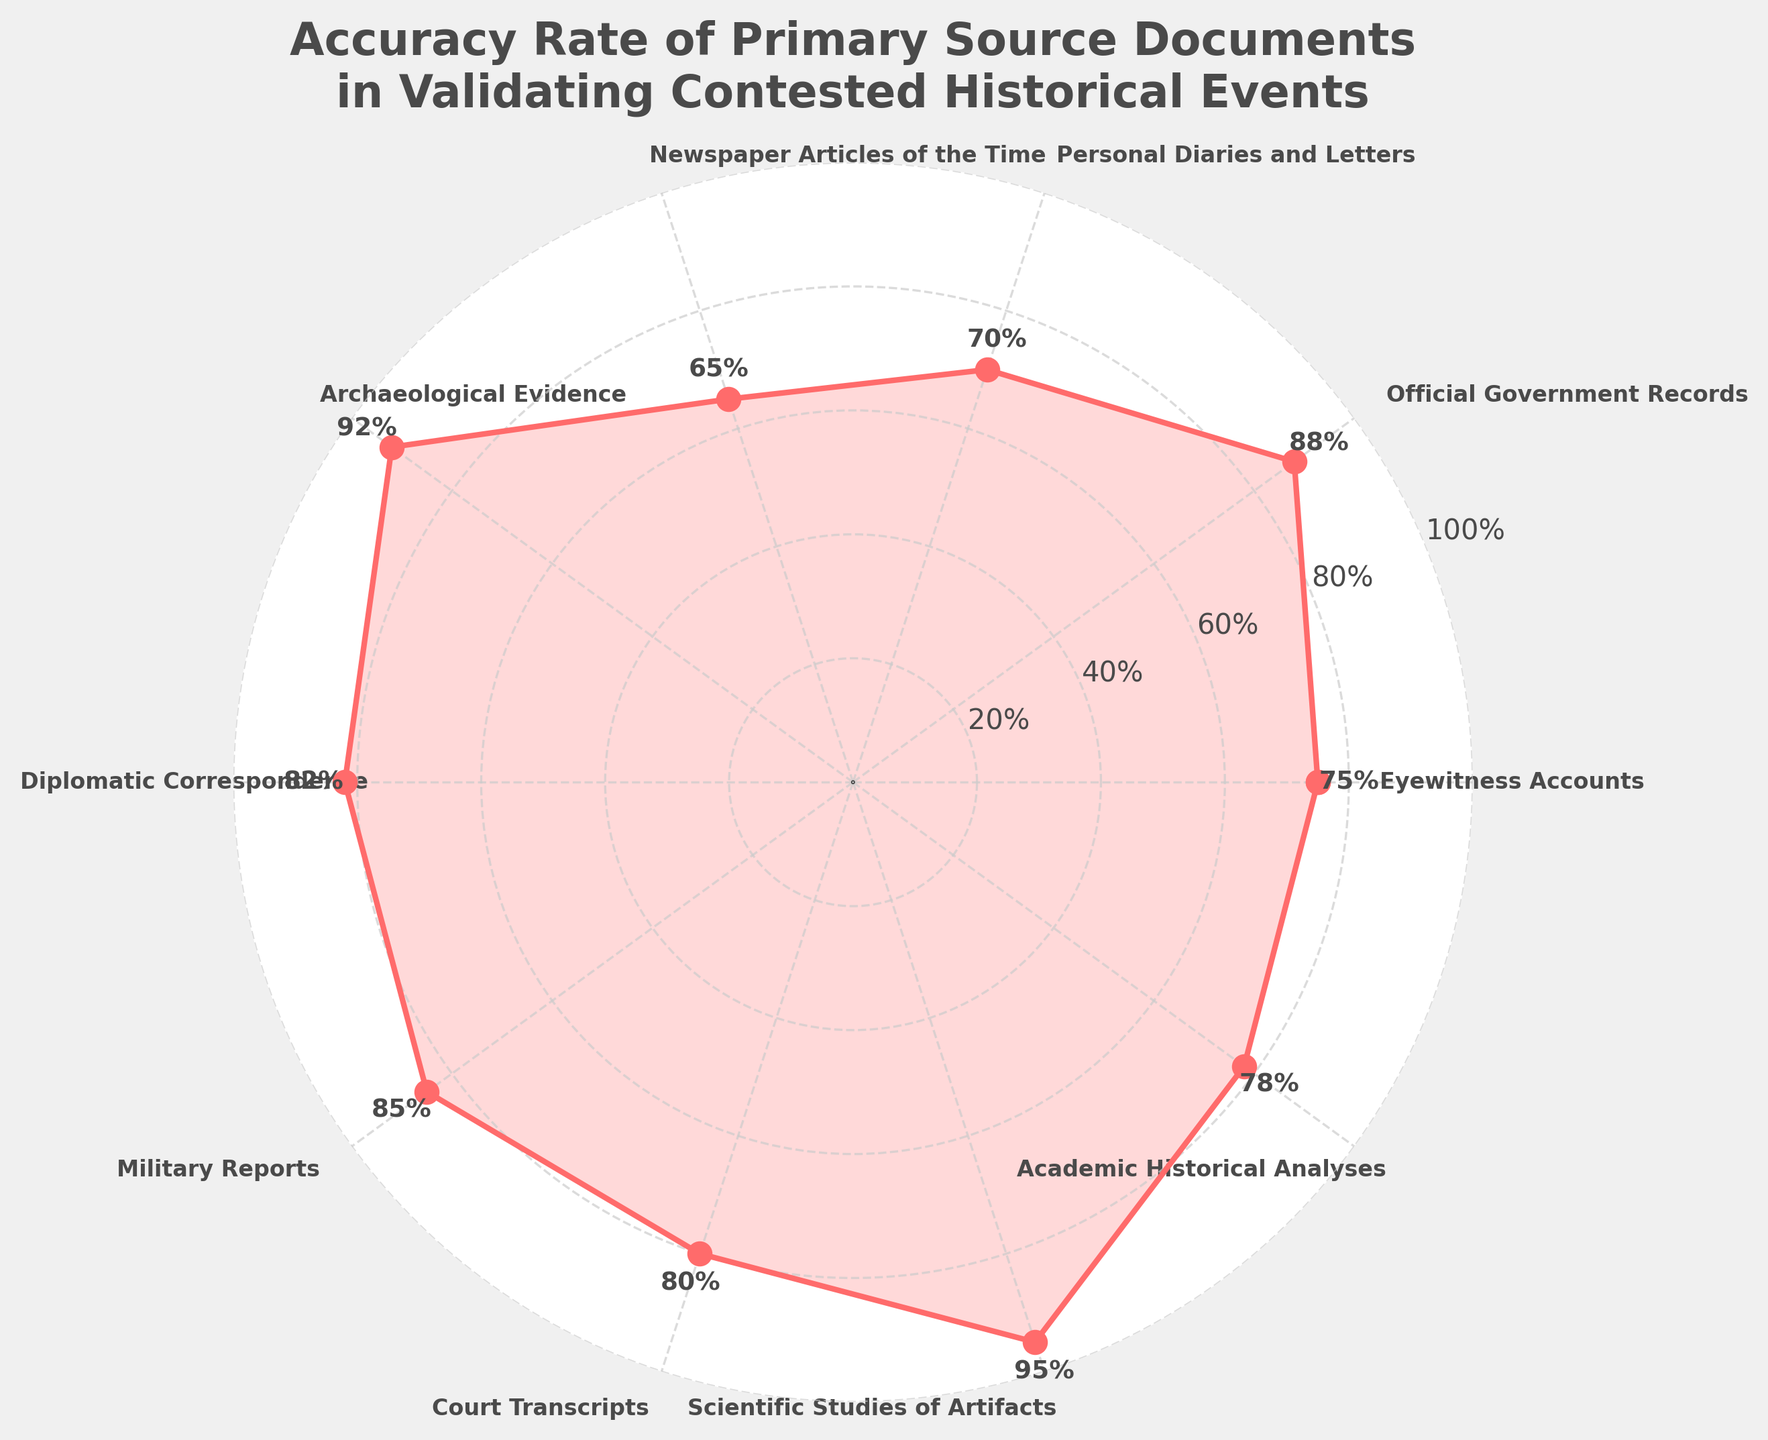What is the title of the figure? The title of the figure is located at the top and is displayed prominently in a bold and slightly larger font compared to other text elements. The wording should be read directly from this title.
Answer: "Accuracy Rate of Primary Source Documents in Validating Contested Historical Events" What category has the highest accuracy rate? Locate the data points on the chart and identify the one with the highest value by examining the radial plot.
Answer: Scientific Studies of Artifacts What is the accuracy rate for Newspaper Articles of the Time? Find the category labeled "Newspaper Articles of the Time" around the circumference of the plot. Follow the associated data point to the labeled accuracy rate value.
Answer: 65% How many categories have an accuracy rate greater than 80%? Identify data points that exceed the 80% mark by examining the plotted values and counting those meeting the criteria.
Answer: 5 Which two categories have the closest accuracy rates, and what are they? Compare the values of all pairs of categories to find the smallest difference between their accuracy rates.
Answer: Personal Diaries and Letters (70%) and Newspaper Articles of the Time (65%) What is the difference between the highest and lowest accuracy rates? Determine the highest value and the lowest value from the radial plot, then subtract the lowest from the highest to find the difference.
Answer: 95% - 65% = 30% Which category is labeled directly opposite to Archaeological Evidence on the plot? Observe the placement of “Archaeological Evidence” on the radial plot and look for the category situated diametrically opposite to it.
Answer: Personal Diaries and Letters What is the average accuracy rate of all the categories? Sum up all the accuracy rates of the categories and divide by the number of categories to find the average.
Answer: (75 + 88 + 70 + 65 + 92 + 82 + 85 + 80 + 95 + 78) / 10 = 80.5% Which category has an accuracy rate that is exactly the median value among all the categories? List all the accuracy rates in ascending order, and find the middle value since there are an even number of categories, the median will be the average of the 5th and 6th values.
Answer: Median is (78+80)/2 = 79%; matching category is Court Transcripts 